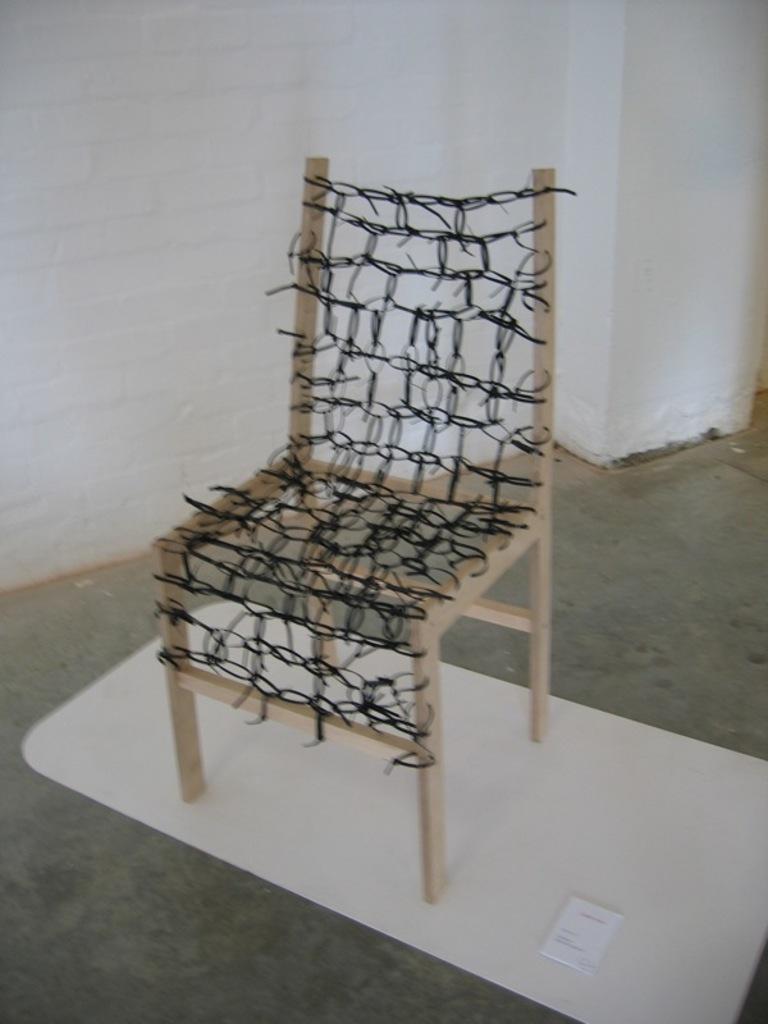How would you summarize this image in a sentence or two? In this image I can see a chair on the floor. In the background, I can see the wall. 